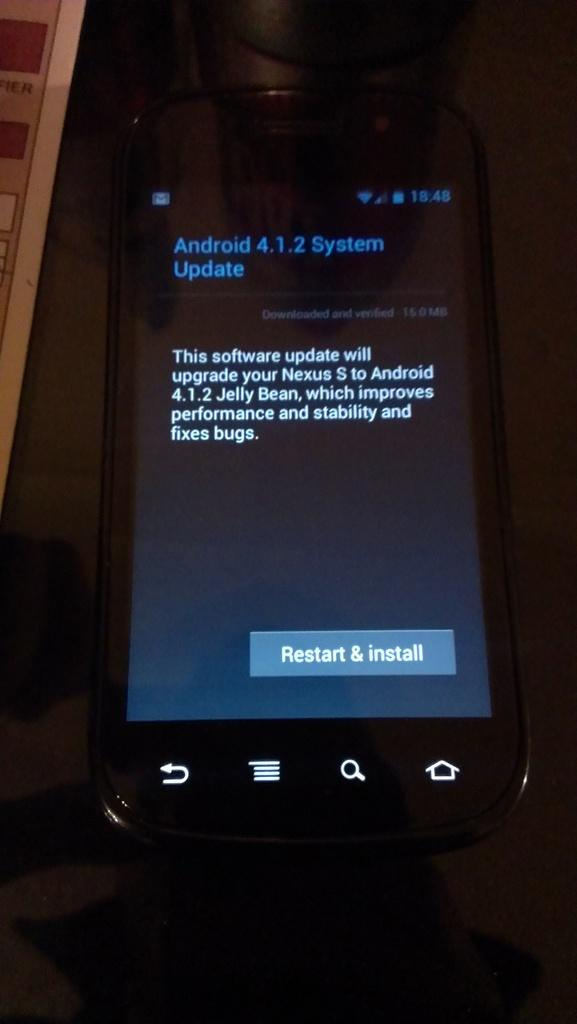<image>
Create a compact narrative representing the image presented. Black android phone that needs a system update 